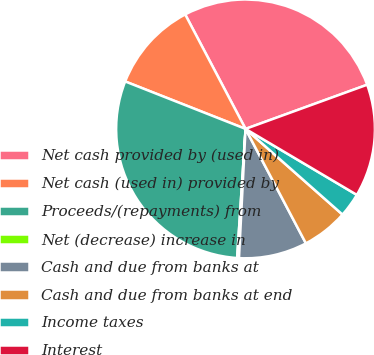Convert chart to OTSL. <chart><loc_0><loc_0><loc_500><loc_500><pie_chart><fcel>Net cash provided by (used in)<fcel>Net cash (used in) provided by<fcel>Proceeds/(repayments) from<fcel>Net (decrease) increase in<fcel>Cash and due from banks at<fcel>Cash and due from banks at end<fcel>Income taxes<fcel>Interest<nl><fcel>27.18%<fcel>11.3%<fcel>29.94%<fcel>0.23%<fcel>8.53%<fcel>5.76%<fcel>3.0%<fcel>14.06%<nl></chart> 